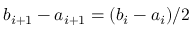<formula> <loc_0><loc_0><loc_500><loc_500>b _ { i + 1 } - a _ { i + 1 } = ( b _ { i } - a _ { i } ) / 2</formula> 